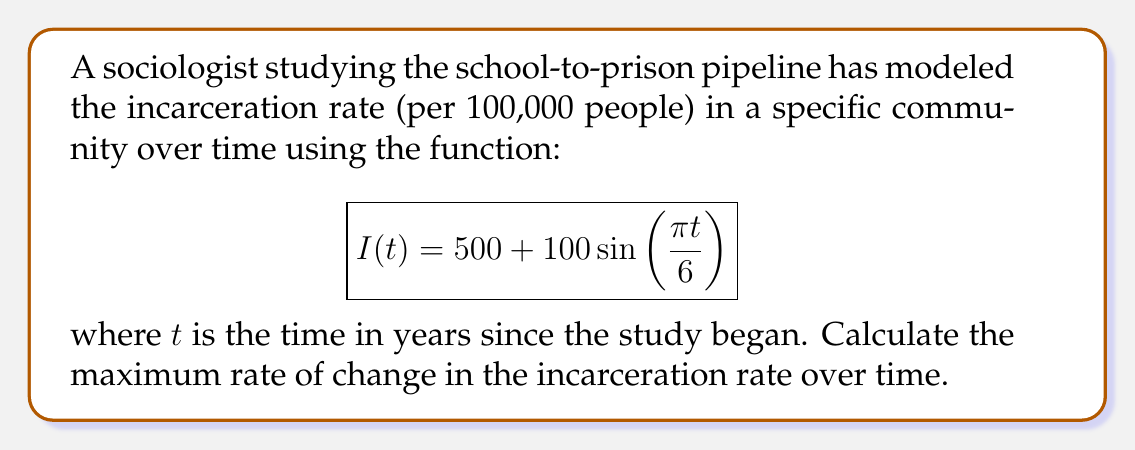Can you solve this math problem? To find the maximum rate of change, we need to follow these steps:

1) The rate of change is given by the derivative of $I(t)$ with respect to $t$. Let's call this $I'(t)$.

2) Differentiate $I(t)$:
   $$I'(t) = 100 \cdot \frac{\pi}{6} \cos(\frac{\pi t}{6}) = \frac{50\pi}{3} \cos(\frac{\pi t}{6})$$

3) The maximum rate of change will occur when $\cos(\frac{\pi t}{6})$ is at its maximum value, which is 1.

4) Therefore, the maximum rate of change is:
   $$\text{Max rate of change} = \left|\frac{50\pi}{3}\right| \approx 52.36$$

5) The negative of this value will give the minimum rate of change, occurring when $\cos(\frac{\pi t}{6}) = -1$.

This result indicates that the incarceration rate is changing most rapidly at a rate of approximately 52.36 per 100,000 people per year, either increasing or decreasing depending on the phase of the cycle.
Answer: $\frac{50\pi}{3}$ per 100,000 per year 